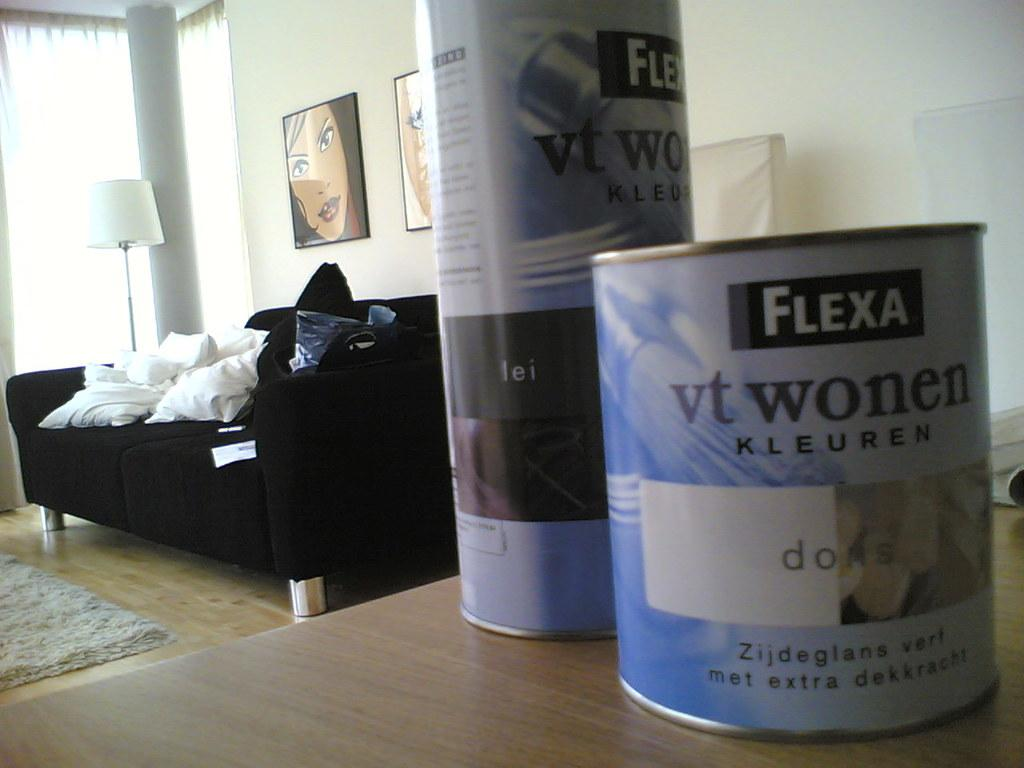<image>
Write a terse but informative summary of the picture. A few containers of FLEXA vt wonen KLEUREN is on a table with a couch and lamp behind them. 